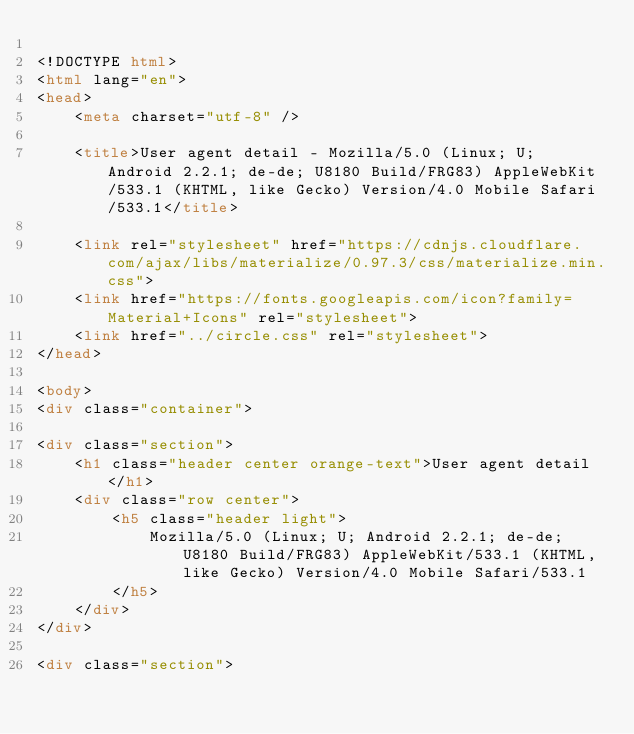Convert code to text. <code><loc_0><loc_0><loc_500><loc_500><_HTML_>
<!DOCTYPE html>
<html lang="en">
<head>
    <meta charset="utf-8" />
            
    <title>User agent detail - Mozilla/5.0 (Linux; U; Android 2.2.1; de-de; U8180 Build/FRG83) AppleWebKit/533.1 (KHTML, like Gecko) Version/4.0 Mobile Safari/533.1</title>
        
    <link rel="stylesheet" href="https://cdnjs.cloudflare.com/ajax/libs/materialize/0.97.3/css/materialize.min.css">
    <link href="https://fonts.googleapis.com/icon?family=Material+Icons" rel="stylesheet">
    <link href="../circle.css" rel="stylesheet">
</head>
        
<body>
<div class="container">
    
<div class="section">
	<h1 class="header center orange-text">User agent detail</h1>
	<div class="row center">
        <h5 class="header light">
            Mozilla/5.0 (Linux; U; Android 2.2.1; de-de; U8180 Build/FRG83) AppleWebKit/533.1 (KHTML, like Gecko) Version/4.0 Mobile Safari/533.1
        </h5>
	</div>
</div>   

<div class="section"></code> 